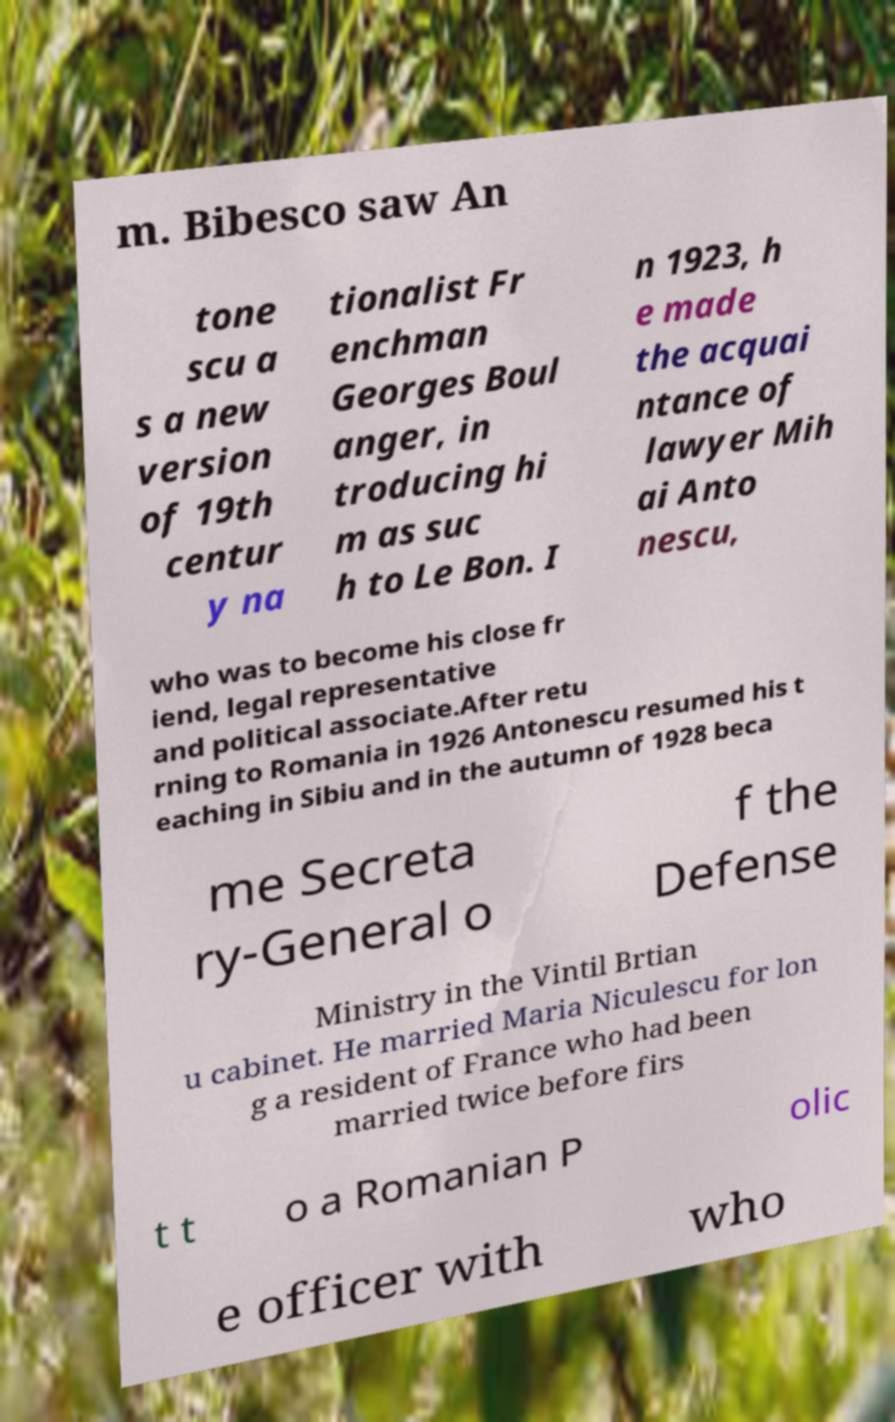I need the written content from this picture converted into text. Can you do that? m. Bibesco saw An tone scu a s a new version of 19th centur y na tionalist Fr enchman Georges Boul anger, in troducing hi m as suc h to Le Bon. I n 1923, h e made the acquai ntance of lawyer Mih ai Anto nescu, who was to become his close fr iend, legal representative and political associate.After retu rning to Romania in 1926 Antonescu resumed his t eaching in Sibiu and in the autumn of 1928 beca me Secreta ry-General o f the Defense Ministry in the Vintil Brtian u cabinet. He married Maria Niculescu for lon g a resident of France who had been married twice before firs t t o a Romanian P olic e officer with who 